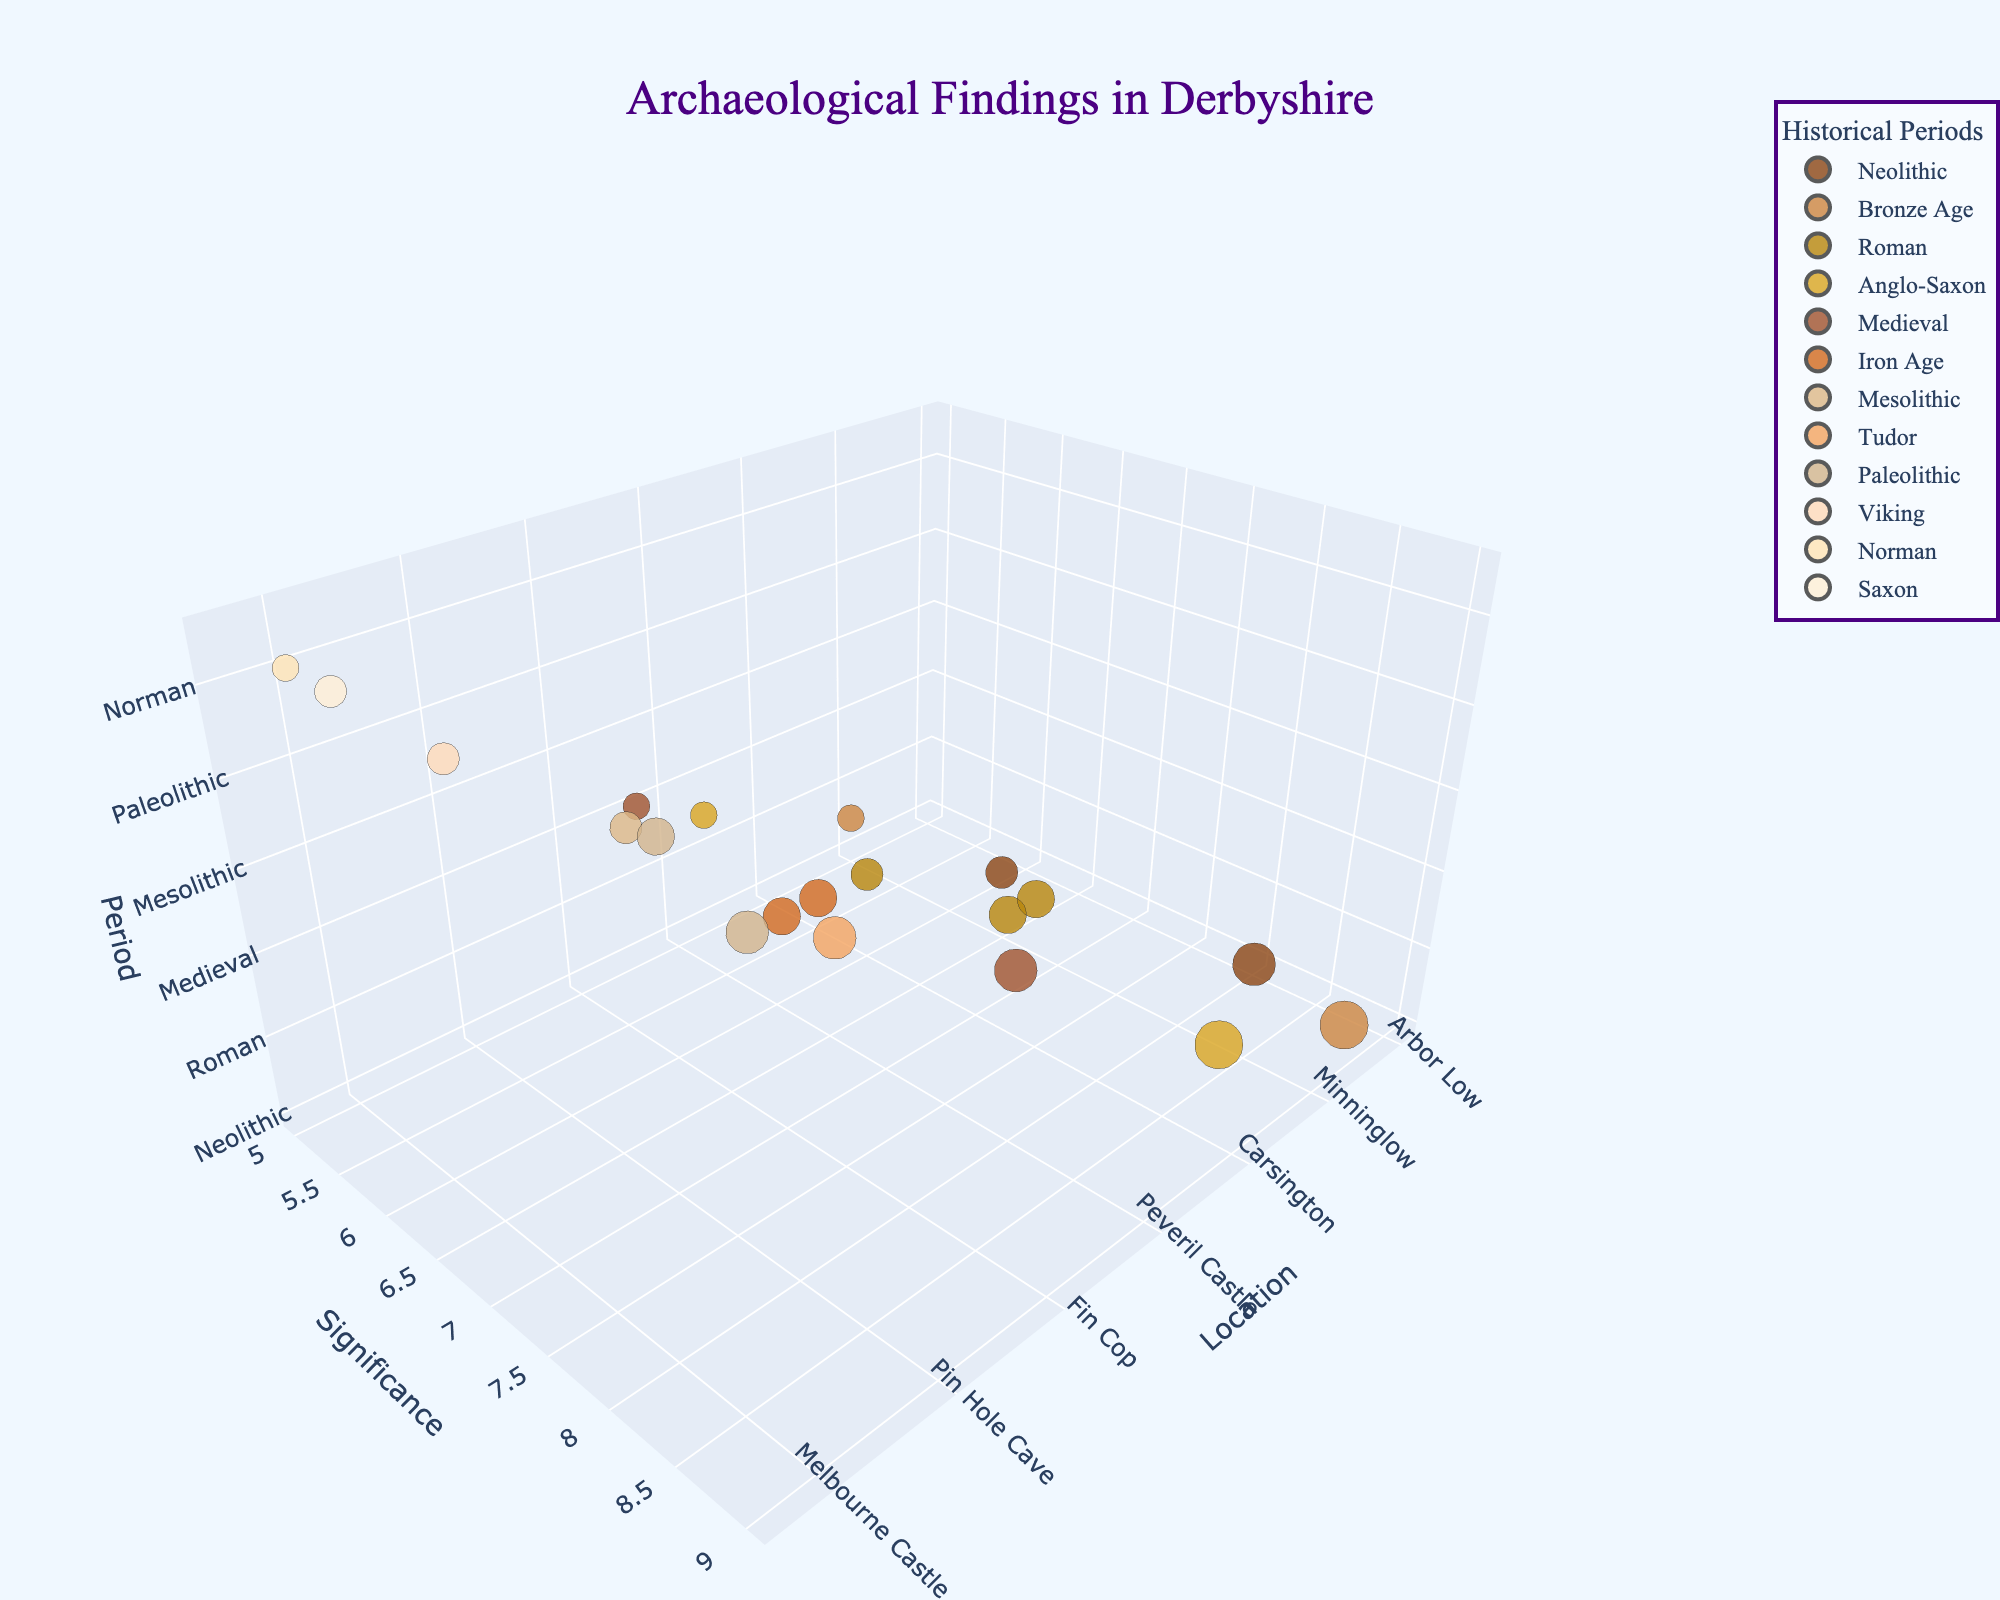What is the title of the figure? The title is displayed at the top of the figure.
Answer: Archaeological Findings in Derbyshire How many historical periods are represented in the plot? Count the unique period labels in the figure.
Answer: 12 Which archaeological finding has the highest significance value? Look for the largest bubble in the plot and note its finding.
Answer: Cave art and artifacts Which location corresponds to the Anglo-Saxon period with a significance of 9? Locate the bubble with 'Anglo-Saxon' and significance of 9 on the significance axis.
Answer: Repton What is the average significance of findings in the Iron Age? Locate and average the values of the bubbles categorized as 'Iron Age'. The findings are 'Mam Tor' (7) and 'Fin Cop' (7). Average = (7+7)/2.
Answer: 7 Which historical period appears to have the least significant finding? Identify the smallest bubble in the plot and note its period.
Answer: Norman Compare the significance between the findings in Arbor Low and Creswell Crags. Which is more significant? Check the sizes and values on the significance axis for 'Arbor Low' and 'Creswell Crags'. Arbor Low has a significance of 8, while Creswell Crags is 9.
Answer: Creswell Crags How many findings have a significance value greater than 7? Count the bubbles with significance values above 7. Findings are in Arbor Low (8), Creswell Crags (9), Repton (9), Peveril Castle (8), and Church Hole Cave (8) totaling 5.
Answer: 5 Which period has findings spread across the most locations? Identify the number of unique locations per period and pick the one with the highest number.
Answer: Roman What is the finding at Little Chester and what is its significance? Locate 'Little Chester' on the location axis and note its corresponding finding and significance.
Answer: Roman fort remains, 7 